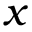<formula> <loc_0><loc_0><loc_500><loc_500>x</formula> 